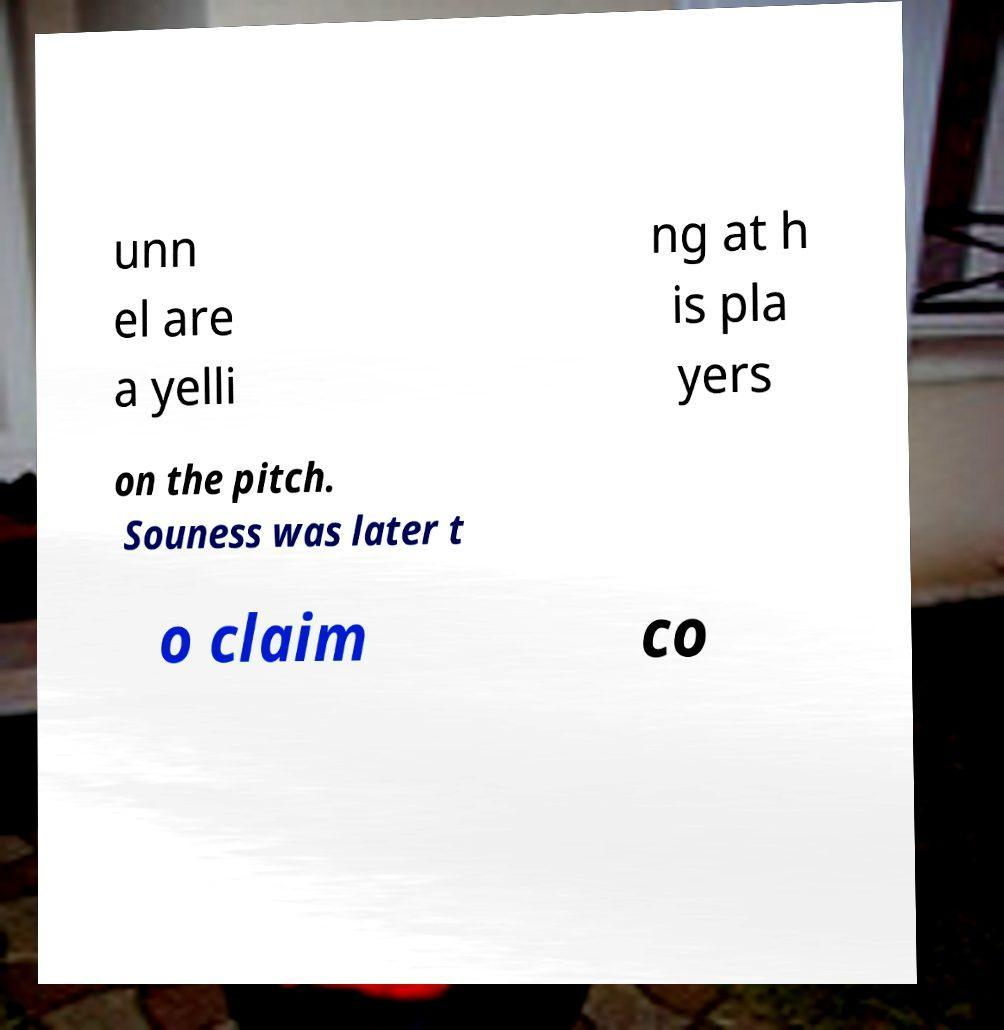Please read and relay the text visible in this image. What does it say? unn el are a yelli ng at h is pla yers on the pitch. Souness was later t o claim co 